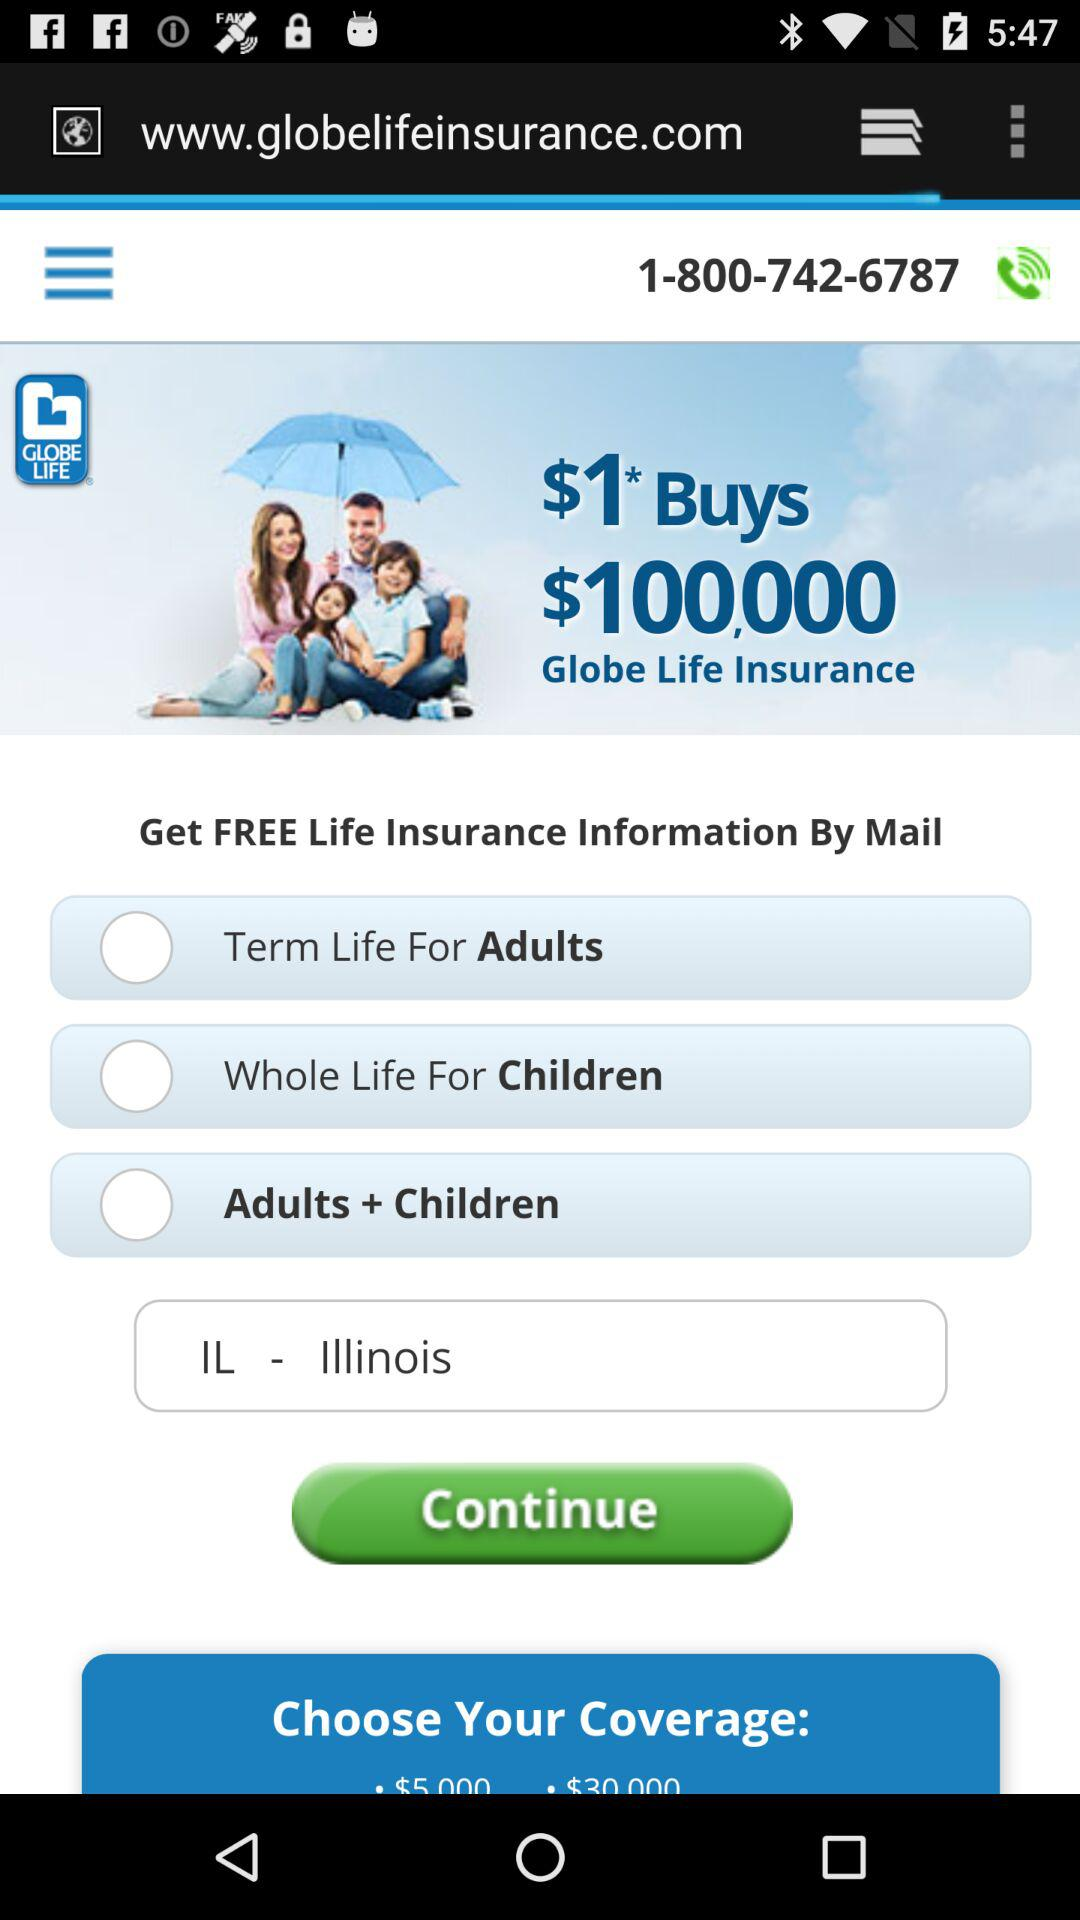Can you tell me what the fine print might imply with the statement '$1* Buys $100,000'? The asterisk next to the $1 typically indicates there is additional information or conditions related to the offer. This is common in advertising, where details are provided in fine print that may clarify the terms of the offer, like initial rates, future commitments, or eligibility criteria. What kind of benefits might this type of insurance provide? While the specifics are not detailed in the image, generally, life insurance like the types advertised could provide financial protection to beneficiaries in the event of the policyholder's death, potentially covering things like final expenses, outstanding debts, and income replacement for dependents. 